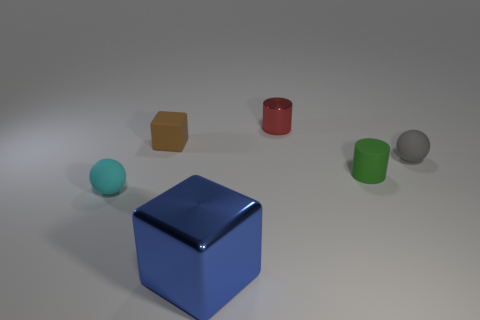Add 2 gray rubber objects. How many objects exist? 8 Subtract 0 green spheres. How many objects are left? 6 Subtract all cubes. How many objects are left? 4 Subtract all big matte balls. Subtract all small brown things. How many objects are left? 5 Add 1 brown cubes. How many brown cubes are left? 2 Add 2 purple metal cylinders. How many purple metal cylinders exist? 2 